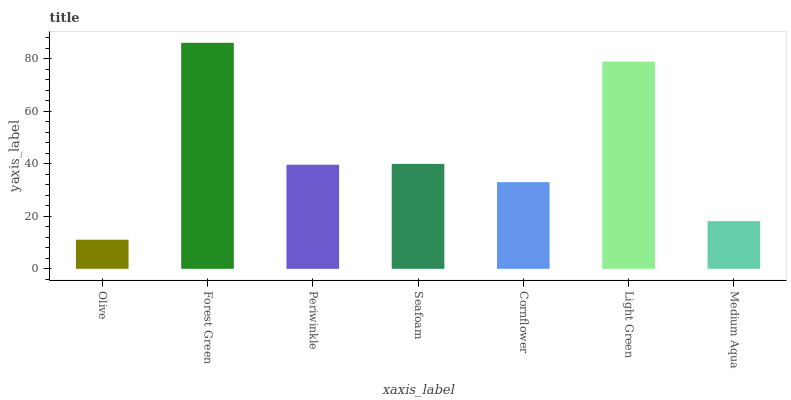Is Periwinkle the minimum?
Answer yes or no. No. Is Periwinkle the maximum?
Answer yes or no. No. Is Forest Green greater than Periwinkle?
Answer yes or no. Yes. Is Periwinkle less than Forest Green?
Answer yes or no. Yes. Is Periwinkle greater than Forest Green?
Answer yes or no. No. Is Forest Green less than Periwinkle?
Answer yes or no. No. Is Periwinkle the high median?
Answer yes or no. Yes. Is Periwinkle the low median?
Answer yes or no. Yes. Is Cornflower the high median?
Answer yes or no. No. Is Light Green the low median?
Answer yes or no. No. 